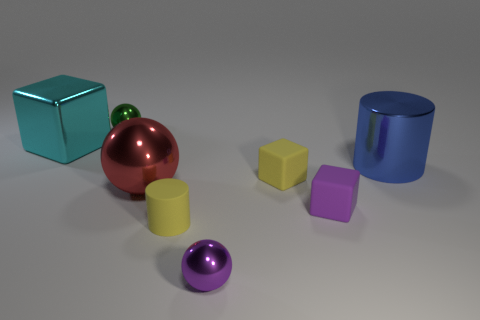How many objects are shown in the image, and can you describe their colors and shapes? The image displays a total of six objects. Starting from the left, there is a teal cube, a small green sphere, a large red sphere, a yellow cube, a violet cube, and a blue cylinder. Their shapes are simple geometric forms: cubes, a sphere, and a cylindrical shape. 